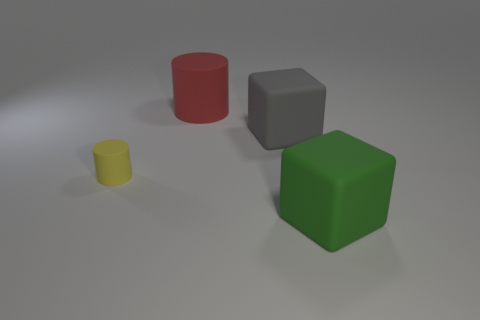What material is the green block? rubber 